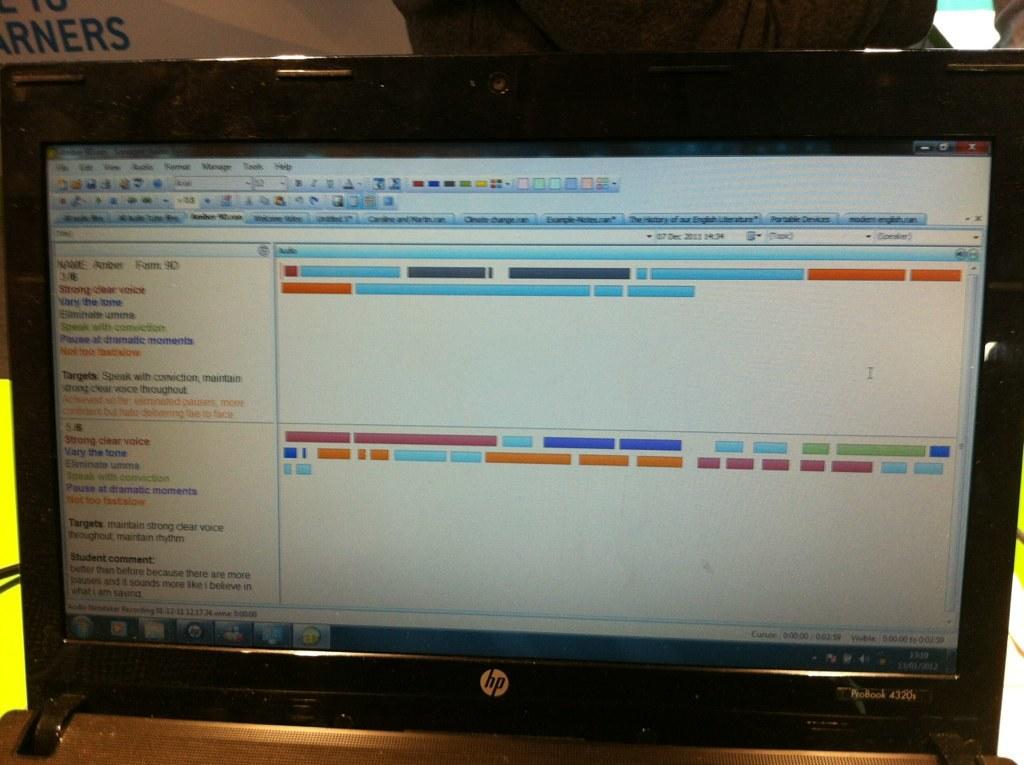What brand of computer?
Keep it short and to the point. Hp. What model is the computer monitor?
Offer a very short reply. Hp. 